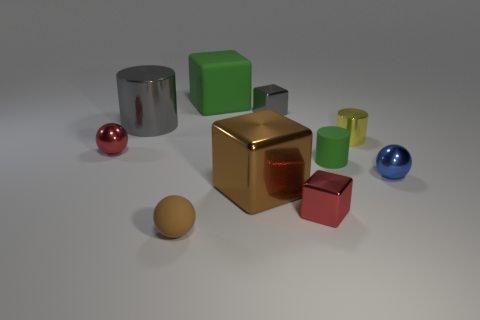What number of other objects are the same size as the rubber cylinder?
Provide a succinct answer. 6. The small red object in front of the tiny shiny ball that is right of the big green rubber cube is what shape?
Provide a succinct answer. Cube. There is a tiny shiny cube that is in front of the big shiny cube; is its color the same as the big block that is behind the small blue object?
Ensure brevity in your answer.  No. Is there any other thing that has the same color as the large metallic cylinder?
Ensure brevity in your answer.  Yes. The small rubber cylinder has what color?
Keep it short and to the point. Green. Are any cubes visible?
Your answer should be very brief. Yes. There is a small gray block; are there any small green matte cylinders to the right of it?
Your response must be concise. Yes. What material is the other red object that is the same shape as the big matte object?
Your answer should be compact. Metal. Is there any other thing that is the same material as the small green thing?
Ensure brevity in your answer.  Yes. What number of other things are the same shape as the small brown object?
Make the answer very short. 2. 